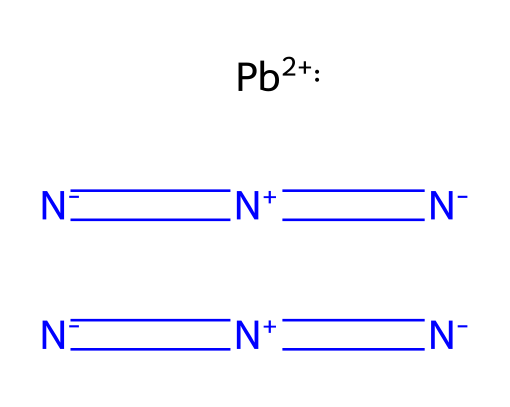what is the molecular formula of lead azide? By analyzing the SMILES representation, we can identify that there are three azide groups (each represented by [N-]=[N+]=[N-]) connected to a lead atom ([Pb+2]). The formula consists of 3 nitrogen atoms from each azide and 1 lead atom, leading to the formula Pb(N3)2.
Answer: Pb(N3)2 how many nitrogen atoms are present in this compound? In the SMILES representation, there are three azide groups, making it 3 nitrogen atoms per azide. However, because lead azide consists of two azides, we multiply the number of nitrogen atoms from one azide (3) by 2 (the number of azides), yielding a total of 6 nitrogen atoms.
Answer: 6 what charge does the lead atom carry in lead azide? The notation [Pb+2] in the SMILES shows that the lead atom has a +2 charge, indicating its oxidation state in this compound.
Answer: +2 which type of chemical compound does lead azide belong to? Lead azide is classified as an azide compound due to the presence of the azide functional group (N3). The distinct characteristic of this group is that it contains three nitrogen atoms connected in a linear arrangement.
Answer: azide how many total bonds are present in lead azide? Each azide group has three bonds due to the triple bond between two nitrogen atoms and one bond connecting to the lead atom. Since there are two azides, it results in 6 bonds from the azides plus 1 bond to the lead atom, for a total of 7 bonds.
Answer: 7 what is the arrangement of nitrogen atoms in an azide group? In an azide group, the nitrogen atoms are arranged in a linear fashion, where the first nitrogen is connected by a triple bond to the second nitrogen, which is then connected by a single bond to the third nitrogen. This linear arrangement is crucial for the azide's reactivity.
Answer: linear 